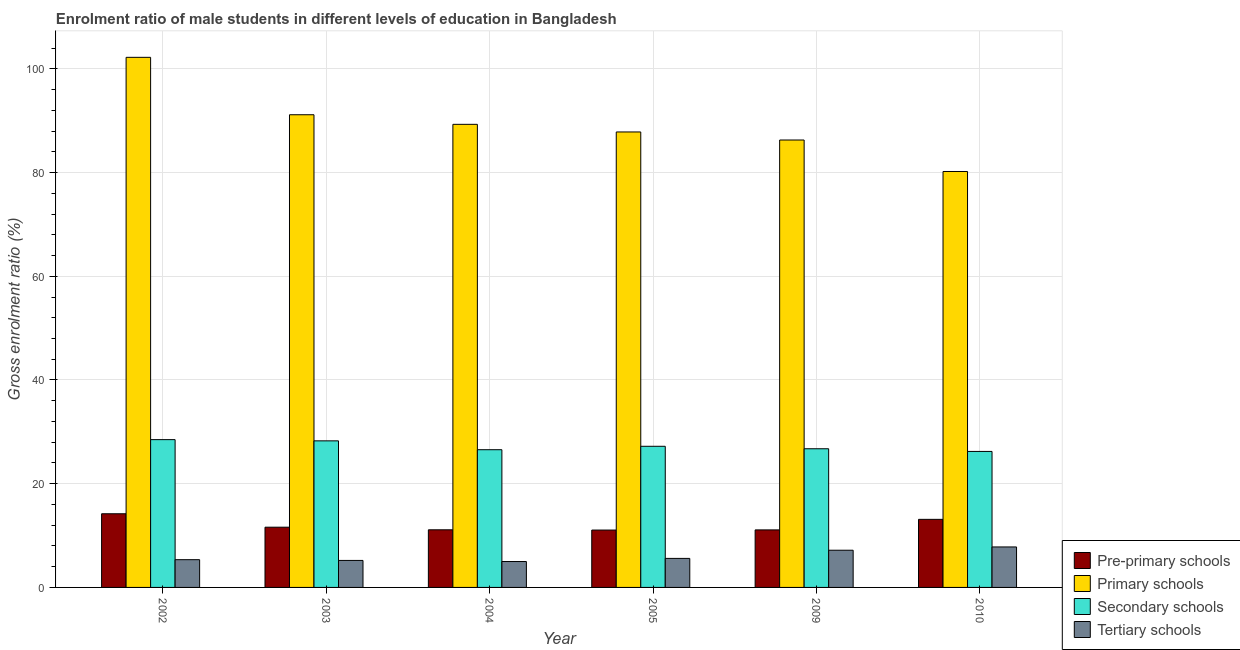How many different coloured bars are there?
Your response must be concise. 4. How many groups of bars are there?
Keep it short and to the point. 6. What is the label of the 3rd group of bars from the left?
Give a very brief answer. 2004. In how many cases, is the number of bars for a given year not equal to the number of legend labels?
Give a very brief answer. 0. What is the gross enrolment ratio(female) in tertiary schools in 2004?
Provide a short and direct response. 5. Across all years, what is the maximum gross enrolment ratio(female) in secondary schools?
Your answer should be very brief. 28.5. Across all years, what is the minimum gross enrolment ratio(female) in tertiary schools?
Make the answer very short. 5. In which year was the gross enrolment ratio(female) in pre-primary schools maximum?
Keep it short and to the point. 2002. What is the total gross enrolment ratio(female) in tertiary schools in the graph?
Your answer should be very brief. 36.13. What is the difference between the gross enrolment ratio(female) in tertiary schools in 2003 and that in 2004?
Ensure brevity in your answer.  0.21. What is the difference between the gross enrolment ratio(female) in primary schools in 2004 and the gross enrolment ratio(female) in pre-primary schools in 2010?
Make the answer very short. 9.09. What is the average gross enrolment ratio(female) in primary schools per year?
Ensure brevity in your answer.  89.5. In the year 2009, what is the difference between the gross enrolment ratio(female) in primary schools and gross enrolment ratio(female) in pre-primary schools?
Your response must be concise. 0. What is the ratio of the gross enrolment ratio(female) in secondary schools in 2009 to that in 2010?
Your response must be concise. 1.02. What is the difference between the highest and the second highest gross enrolment ratio(female) in pre-primary schools?
Your answer should be very brief. 1.08. What is the difference between the highest and the lowest gross enrolment ratio(female) in pre-primary schools?
Make the answer very short. 3.14. Is the sum of the gross enrolment ratio(female) in primary schools in 2005 and 2009 greater than the maximum gross enrolment ratio(female) in pre-primary schools across all years?
Provide a short and direct response. Yes. What does the 1st bar from the left in 2003 represents?
Provide a short and direct response. Pre-primary schools. What does the 4th bar from the right in 2004 represents?
Provide a short and direct response. Pre-primary schools. Are all the bars in the graph horizontal?
Offer a terse response. No. Are the values on the major ticks of Y-axis written in scientific E-notation?
Keep it short and to the point. No. Does the graph contain grids?
Make the answer very short. Yes. Where does the legend appear in the graph?
Your response must be concise. Bottom right. How are the legend labels stacked?
Give a very brief answer. Vertical. What is the title of the graph?
Provide a succinct answer. Enrolment ratio of male students in different levels of education in Bangladesh. What is the label or title of the X-axis?
Offer a terse response. Year. What is the Gross enrolment ratio (%) in Pre-primary schools in 2002?
Your answer should be compact. 14.21. What is the Gross enrolment ratio (%) of Primary schools in 2002?
Give a very brief answer. 102.22. What is the Gross enrolment ratio (%) in Secondary schools in 2002?
Make the answer very short. 28.5. What is the Gross enrolment ratio (%) in Tertiary schools in 2002?
Make the answer very short. 5.35. What is the Gross enrolment ratio (%) in Pre-primary schools in 2003?
Make the answer very short. 11.61. What is the Gross enrolment ratio (%) in Primary schools in 2003?
Give a very brief answer. 91.15. What is the Gross enrolment ratio (%) in Secondary schools in 2003?
Your response must be concise. 28.26. What is the Gross enrolment ratio (%) in Tertiary schools in 2003?
Offer a terse response. 5.2. What is the Gross enrolment ratio (%) of Pre-primary schools in 2004?
Offer a terse response. 11.11. What is the Gross enrolment ratio (%) of Primary schools in 2004?
Offer a very short reply. 89.3. What is the Gross enrolment ratio (%) of Secondary schools in 2004?
Offer a very short reply. 26.56. What is the Gross enrolment ratio (%) of Tertiary schools in 2004?
Offer a very short reply. 5. What is the Gross enrolment ratio (%) in Pre-primary schools in 2005?
Provide a short and direct response. 11.06. What is the Gross enrolment ratio (%) in Primary schools in 2005?
Make the answer very short. 87.83. What is the Gross enrolment ratio (%) of Secondary schools in 2005?
Offer a very short reply. 27.22. What is the Gross enrolment ratio (%) of Tertiary schools in 2005?
Provide a succinct answer. 5.6. What is the Gross enrolment ratio (%) of Pre-primary schools in 2009?
Give a very brief answer. 11.09. What is the Gross enrolment ratio (%) of Primary schools in 2009?
Make the answer very short. 86.28. What is the Gross enrolment ratio (%) of Secondary schools in 2009?
Make the answer very short. 26.74. What is the Gross enrolment ratio (%) of Tertiary schools in 2009?
Your answer should be very brief. 7.17. What is the Gross enrolment ratio (%) in Pre-primary schools in 2010?
Your response must be concise. 13.13. What is the Gross enrolment ratio (%) in Primary schools in 2010?
Offer a very short reply. 80.21. What is the Gross enrolment ratio (%) of Secondary schools in 2010?
Provide a short and direct response. 26.23. What is the Gross enrolment ratio (%) of Tertiary schools in 2010?
Make the answer very short. 7.81. Across all years, what is the maximum Gross enrolment ratio (%) in Pre-primary schools?
Give a very brief answer. 14.21. Across all years, what is the maximum Gross enrolment ratio (%) in Primary schools?
Offer a very short reply. 102.22. Across all years, what is the maximum Gross enrolment ratio (%) of Secondary schools?
Your response must be concise. 28.5. Across all years, what is the maximum Gross enrolment ratio (%) of Tertiary schools?
Your response must be concise. 7.81. Across all years, what is the minimum Gross enrolment ratio (%) of Pre-primary schools?
Make the answer very short. 11.06. Across all years, what is the minimum Gross enrolment ratio (%) in Primary schools?
Provide a succinct answer. 80.21. Across all years, what is the minimum Gross enrolment ratio (%) of Secondary schools?
Offer a very short reply. 26.23. Across all years, what is the minimum Gross enrolment ratio (%) of Tertiary schools?
Provide a succinct answer. 5. What is the total Gross enrolment ratio (%) of Pre-primary schools in the graph?
Ensure brevity in your answer.  72.22. What is the total Gross enrolment ratio (%) of Primary schools in the graph?
Offer a terse response. 536.99. What is the total Gross enrolment ratio (%) in Secondary schools in the graph?
Provide a short and direct response. 163.51. What is the total Gross enrolment ratio (%) in Tertiary schools in the graph?
Offer a very short reply. 36.13. What is the difference between the Gross enrolment ratio (%) of Pre-primary schools in 2002 and that in 2003?
Keep it short and to the point. 2.59. What is the difference between the Gross enrolment ratio (%) in Primary schools in 2002 and that in 2003?
Give a very brief answer. 11.07. What is the difference between the Gross enrolment ratio (%) of Secondary schools in 2002 and that in 2003?
Ensure brevity in your answer.  0.24. What is the difference between the Gross enrolment ratio (%) in Tertiary schools in 2002 and that in 2003?
Make the answer very short. 0.15. What is the difference between the Gross enrolment ratio (%) in Pre-primary schools in 2002 and that in 2004?
Offer a very short reply. 3.09. What is the difference between the Gross enrolment ratio (%) of Primary schools in 2002 and that in 2004?
Give a very brief answer. 12.92. What is the difference between the Gross enrolment ratio (%) of Secondary schools in 2002 and that in 2004?
Make the answer very short. 1.94. What is the difference between the Gross enrolment ratio (%) in Tertiary schools in 2002 and that in 2004?
Ensure brevity in your answer.  0.36. What is the difference between the Gross enrolment ratio (%) in Pre-primary schools in 2002 and that in 2005?
Offer a terse response. 3.14. What is the difference between the Gross enrolment ratio (%) of Primary schools in 2002 and that in 2005?
Offer a terse response. 14.39. What is the difference between the Gross enrolment ratio (%) in Secondary schools in 2002 and that in 2005?
Your response must be concise. 1.28. What is the difference between the Gross enrolment ratio (%) of Tertiary schools in 2002 and that in 2005?
Ensure brevity in your answer.  -0.24. What is the difference between the Gross enrolment ratio (%) in Pre-primary schools in 2002 and that in 2009?
Make the answer very short. 3.11. What is the difference between the Gross enrolment ratio (%) of Primary schools in 2002 and that in 2009?
Your answer should be very brief. 15.94. What is the difference between the Gross enrolment ratio (%) of Secondary schools in 2002 and that in 2009?
Make the answer very short. 1.76. What is the difference between the Gross enrolment ratio (%) in Tertiary schools in 2002 and that in 2009?
Your answer should be compact. -1.82. What is the difference between the Gross enrolment ratio (%) in Pre-primary schools in 2002 and that in 2010?
Ensure brevity in your answer.  1.08. What is the difference between the Gross enrolment ratio (%) of Primary schools in 2002 and that in 2010?
Provide a succinct answer. 22.01. What is the difference between the Gross enrolment ratio (%) of Secondary schools in 2002 and that in 2010?
Your answer should be very brief. 2.28. What is the difference between the Gross enrolment ratio (%) in Tertiary schools in 2002 and that in 2010?
Ensure brevity in your answer.  -2.46. What is the difference between the Gross enrolment ratio (%) of Pre-primary schools in 2003 and that in 2004?
Keep it short and to the point. 0.5. What is the difference between the Gross enrolment ratio (%) in Primary schools in 2003 and that in 2004?
Ensure brevity in your answer.  1.85. What is the difference between the Gross enrolment ratio (%) of Secondary schools in 2003 and that in 2004?
Make the answer very short. 1.71. What is the difference between the Gross enrolment ratio (%) of Tertiary schools in 2003 and that in 2004?
Offer a terse response. 0.21. What is the difference between the Gross enrolment ratio (%) of Pre-primary schools in 2003 and that in 2005?
Your response must be concise. 0.55. What is the difference between the Gross enrolment ratio (%) of Primary schools in 2003 and that in 2005?
Your answer should be compact. 3.32. What is the difference between the Gross enrolment ratio (%) of Secondary schools in 2003 and that in 2005?
Make the answer very short. 1.05. What is the difference between the Gross enrolment ratio (%) in Tertiary schools in 2003 and that in 2005?
Offer a terse response. -0.39. What is the difference between the Gross enrolment ratio (%) in Pre-primary schools in 2003 and that in 2009?
Ensure brevity in your answer.  0.52. What is the difference between the Gross enrolment ratio (%) in Primary schools in 2003 and that in 2009?
Your answer should be very brief. 4.87. What is the difference between the Gross enrolment ratio (%) of Secondary schools in 2003 and that in 2009?
Offer a very short reply. 1.52. What is the difference between the Gross enrolment ratio (%) in Tertiary schools in 2003 and that in 2009?
Your answer should be compact. -1.97. What is the difference between the Gross enrolment ratio (%) in Pre-primary schools in 2003 and that in 2010?
Offer a terse response. -1.51. What is the difference between the Gross enrolment ratio (%) in Primary schools in 2003 and that in 2010?
Ensure brevity in your answer.  10.94. What is the difference between the Gross enrolment ratio (%) of Secondary schools in 2003 and that in 2010?
Ensure brevity in your answer.  2.04. What is the difference between the Gross enrolment ratio (%) in Tertiary schools in 2003 and that in 2010?
Your response must be concise. -2.6. What is the difference between the Gross enrolment ratio (%) of Pre-primary schools in 2004 and that in 2005?
Ensure brevity in your answer.  0.05. What is the difference between the Gross enrolment ratio (%) of Primary schools in 2004 and that in 2005?
Keep it short and to the point. 1.47. What is the difference between the Gross enrolment ratio (%) of Secondary schools in 2004 and that in 2005?
Give a very brief answer. -0.66. What is the difference between the Gross enrolment ratio (%) of Tertiary schools in 2004 and that in 2005?
Provide a short and direct response. -0.6. What is the difference between the Gross enrolment ratio (%) in Pre-primary schools in 2004 and that in 2009?
Your answer should be compact. 0.02. What is the difference between the Gross enrolment ratio (%) in Primary schools in 2004 and that in 2009?
Your answer should be very brief. 3.02. What is the difference between the Gross enrolment ratio (%) of Secondary schools in 2004 and that in 2009?
Keep it short and to the point. -0.18. What is the difference between the Gross enrolment ratio (%) of Tertiary schools in 2004 and that in 2009?
Ensure brevity in your answer.  -2.18. What is the difference between the Gross enrolment ratio (%) of Pre-primary schools in 2004 and that in 2010?
Offer a terse response. -2.01. What is the difference between the Gross enrolment ratio (%) of Primary schools in 2004 and that in 2010?
Provide a succinct answer. 9.09. What is the difference between the Gross enrolment ratio (%) of Secondary schools in 2004 and that in 2010?
Provide a succinct answer. 0.33. What is the difference between the Gross enrolment ratio (%) in Tertiary schools in 2004 and that in 2010?
Provide a short and direct response. -2.81. What is the difference between the Gross enrolment ratio (%) of Pre-primary schools in 2005 and that in 2009?
Your answer should be compact. -0.03. What is the difference between the Gross enrolment ratio (%) of Primary schools in 2005 and that in 2009?
Your answer should be compact. 1.55. What is the difference between the Gross enrolment ratio (%) of Secondary schools in 2005 and that in 2009?
Offer a very short reply. 0.48. What is the difference between the Gross enrolment ratio (%) of Tertiary schools in 2005 and that in 2009?
Your answer should be very brief. -1.58. What is the difference between the Gross enrolment ratio (%) in Pre-primary schools in 2005 and that in 2010?
Provide a succinct answer. -2.06. What is the difference between the Gross enrolment ratio (%) in Primary schools in 2005 and that in 2010?
Keep it short and to the point. 7.62. What is the difference between the Gross enrolment ratio (%) of Tertiary schools in 2005 and that in 2010?
Give a very brief answer. -2.21. What is the difference between the Gross enrolment ratio (%) in Pre-primary schools in 2009 and that in 2010?
Offer a terse response. -2.03. What is the difference between the Gross enrolment ratio (%) in Primary schools in 2009 and that in 2010?
Make the answer very short. 6.07. What is the difference between the Gross enrolment ratio (%) of Secondary schools in 2009 and that in 2010?
Your response must be concise. 0.52. What is the difference between the Gross enrolment ratio (%) of Tertiary schools in 2009 and that in 2010?
Your answer should be very brief. -0.63. What is the difference between the Gross enrolment ratio (%) in Pre-primary schools in 2002 and the Gross enrolment ratio (%) in Primary schools in 2003?
Make the answer very short. -76.94. What is the difference between the Gross enrolment ratio (%) in Pre-primary schools in 2002 and the Gross enrolment ratio (%) in Secondary schools in 2003?
Provide a short and direct response. -14.06. What is the difference between the Gross enrolment ratio (%) in Pre-primary schools in 2002 and the Gross enrolment ratio (%) in Tertiary schools in 2003?
Make the answer very short. 9. What is the difference between the Gross enrolment ratio (%) in Primary schools in 2002 and the Gross enrolment ratio (%) in Secondary schools in 2003?
Keep it short and to the point. 73.96. What is the difference between the Gross enrolment ratio (%) of Primary schools in 2002 and the Gross enrolment ratio (%) of Tertiary schools in 2003?
Make the answer very short. 97.02. What is the difference between the Gross enrolment ratio (%) in Secondary schools in 2002 and the Gross enrolment ratio (%) in Tertiary schools in 2003?
Your response must be concise. 23.3. What is the difference between the Gross enrolment ratio (%) in Pre-primary schools in 2002 and the Gross enrolment ratio (%) in Primary schools in 2004?
Offer a very short reply. -75.09. What is the difference between the Gross enrolment ratio (%) in Pre-primary schools in 2002 and the Gross enrolment ratio (%) in Secondary schools in 2004?
Keep it short and to the point. -12.35. What is the difference between the Gross enrolment ratio (%) of Pre-primary schools in 2002 and the Gross enrolment ratio (%) of Tertiary schools in 2004?
Your response must be concise. 9.21. What is the difference between the Gross enrolment ratio (%) of Primary schools in 2002 and the Gross enrolment ratio (%) of Secondary schools in 2004?
Make the answer very short. 75.66. What is the difference between the Gross enrolment ratio (%) of Primary schools in 2002 and the Gross enrolment ratio (%) of Tertiary schools in 2004?
Provide a short and direct response. 97.23. What is the difference between the Gross enrolment ratio (%) of Secondary schools in 2002 and the Gross enrolment ratio (%) of Tertiary schools in 2004?
Keep it short and to the point. 23.5. What is the difference between the Gross enrolment ratio (%) in Pre-primary schools in 2002 and the Gross enrolment ratio (%) in Primary schools in 2005?
Keep it short and to the point. -73.63. What is the difference between the Gross enrolment ratio (%) of Pre-primary schools in 2002 and the Gross enrolment ratio (%) of Secondary schools in 2005?
Give a very brief answer. -13.01. What is the difference between the Gross enrolment ratio (%) of Pre-primary schools in 2002 and the Gross enrolment ratio (%) of Tertiary schools in 2005?
Your answer should be compact. 8.61. What is the difference between the Gross enrolment ratio (%) of Primary schools in 2002 and the Gross enrolment ratio (%) of Secondary schools in 2005?
Give a very brief answer. 75.01. What is the difference between the Gross enrolment ratio (%) in Primary schools in 2002 and the Gross enrolment ratio (%) in Tertiary schools in 2005?
Provide a short and direct response. 96.63. What is the difference between the Gross enrolment ratio (%) in Secondary schools in 2002 and the Gross enrolment ratio (%) in Tertiary schools in 2005?
Offer a terse response. 22.9. What is the difference between the Gross enrolment ratio (%) in Pre-primary schools in 2002 and the Gross enrolment ratio (%) in Primary schools in 2009?
Keep it short and to the point. -72.07. What is the difference between the Gross enrolment ratio (%) in Pre-primary schools in 2002 and the Gross enrolment ratio (%) in Secondary schools in 2009?
Make the answer very short. -12.54. What is the difference between the Gross enrolment ratio (%) in Pre-primary schools in 2002 and the Gross enrolment ratio (%) in Tertiary schools in 2009?
Offer a very short reply. 7.03. What is the difference between the Gross enrolment ratio (%) of Primary schools in 2002 and the Gross enrolment ratio (%) of Secondary schools in 2009?
Offer a very short reply. 75.48. What is the difference between the Gross enrolment ratio (%) of Primary schools in 2002 and the Gross enrolment ratio (%) of Tertiary schools in 2009?
Your answer should be very brief. 95.05. What is the difference between the Gross enrolment ratio (%) in Secondary schools in 2002 and the Gross enrolment ratio (%) in Tertiary schools in 2009?
Give a very brief answer. 21.33. What is the difference between the Gross enrolment ratio (%) of Pre-primary schools in 2002 and the Gross enrolment ratio (%) of Primary schools in 2010?
Keep it short and to the point. -66. What is the difference between the Gross enrolment ratio (%) of Pre-primary schools in 2002 and the Gross enrolment ratio (%) of Secondary schools in 2010?
Give a very brief answer. -12.02. What is the difference between the Gross enrolment ratio (%) in Pre-primary schools in 2002 and the Gross enrolment ratio (%) in Tertiary schools in 2010?
Your answer should be very brief. 6.4. What is the difference between the Gross enrolment ratio (%) in Primary schools in 2002 and the Gross enrolment ratio (%) in Secondary schools in 2010?
Give a very brief answer. 76. What is the difference between the Gross enrolment ratio (%) in Primary schools in 2002 and the Gross enrolment ratio (%) in Tertiary schools in 2010?
Your response must be concise. 94.42. What is the difference between the Gross enrolment ratio (%) of Secondary schools in 2002 and the Gross enrolment ratio (%) of Tertiary schools in 2010?
Your response must be concise. 20.69. What is the difference between the Gross enrolment ratio (%) of Pre-primary schools in 2003 and the Gross enrolment ratio (%) of Primary schools in 2004?
Give a very brief answer. -77.69. What is the difference between the Gross enrolment ratio (%) in Pre-primary schools in 2003 and the Gross enrolment ratio (%) in Secondary schools in 2004?
Give a very brief answer. -14.94. What is the difference between the Gross enrolment ratio (%) of Pre-primary schools in 2003 and the Gross enrolment ratio (%) of Tertiary schools in 2004?
Your answer should be very brief. 6.62. What is the difference between the Gross enrolment ratio (%) of Primary schools in 2003 and the Gross enrolment ratio (%) of Secondary schools in 2004?
Provide a succinct answer. 64.59. What is the difference between the Gross enrolment ratio (%) in Primary schools in 2003 and the Gross enrolment ratio (%) in Tertiary schools in 2004?
Provide a succinct answer. 86.15. What is the difference between the Gross enrolment ratio (%) of Secondary schools in 2003 and the Gross enrolment ratio (%) of Tertiary schools in 2004?
Make the answer very short. 23.27. What is the difference between the Gross enrolment ratio (%) in Pre-primary schools in 2003 and the Gross enrolment ratio (%) in Primary schools in 2005?
Offer a terse response. -76.22. What is the difference between the Gross enrolment ratio (%) of Pre-primary schools in 2003 and the Gross enrolment ratio (%) of Secondary schools in 2005?
Give a very brief answer. -15.6. What is the difference between the Gross enrolment ratio (%) in Pre-primary schools in 2003 and the Gross enrolment ratio (%) in Tertiary schools in 2005?
Your response must be concise. 6.02. What is the difference between the Gross enrolment ratio (%) of Primary schools in 2003 and the Gross enrolment ratio (%) of Secondary schools in 2005?
Offer a very short reply. 63.93. What is the difference between the Gross enrolment ratio (%) in Primary schools in 2003 and the Gross enrolment ratio (%) in Tertiary schools in 2005?
Offer a very short reply. 85.55. What is the difference between the Gross enrolment ratio (%) of Secondary schools in 2003 and the Gross enrolment ratio (%) of Tertiary schools in 2005?
Offer a terse response. 22.67. What is the difference between the Gross enrolment ratio (%) in Pre-primary schools in 2003 and the Gross enrolment ratio (%) in Primary schools in 2009?
Your answer should be compact. -74.66. What is the difference between the Gross enrolment ratio (%) in Pre-primary schools in 2003 and the Gross enrolment ratio (%) in Secondary schools in 2009?
Give a very brief answer. -15.13. What is the difference between the Gross enrolment ratio (%) of Pre-primary schools in 2003 and the Gross enrolment ratio (%) of Tertiary schools in 2009?
Give a very brief answer. 4.44. What is the difference between the Gross enrolment ratio (%) in Primary schools in 2003 and the Gross enrolment ratio (%) in Secondary schools in 2009?
Provide a succinct answer. 64.41. What is the difference between the Gross enrolment ratio (%) of Primary schools in 2003 and the Gross enrolment ratio (%) of Tertiary schools in 2009?
Ensure brevity in your answer.  83.98. What is the difference between the Gross enrolment ratio (%) in Secondary schools in 2003 and the Gross enrolment ratio (%) in Tertiary schools in 2009?
Offer a terse response. 21.09. What is the difference between the Gross enrolment ratio (%) of Pre-primary schools in 2003 and the Gross enrolment ratio (%) of Primary schools in 2010?
Your response must be concise. -68.59. What is the difference between the Gross enrolment ratio (%) in Pre-primary schools in 2003 and the Gross enrolment ratio (%) in Secondary schools in 2010?
Offer a very short reply. -14.61. What is the difference between the Gross enrolment ratio (%) of Pre-primary schools in 2003 and the Gross enrolment ratio (%) of Tertiary schools in 2010?
Keep it short and to the point. 3.81. What is the difference between the Gross enrolment ratio (%) in Primary schools in 2003 and the Gross enrolment ratio (%) in Secondary schools in 2010?
Your response must be concise. 64.92. What is the difference between the Gross enrolment ratio (%) of Primary schools in 2003 and the Gross enrolment ratio (%) of Tertiary schools in 2010?
Provide a succinct answer. 83.34. What is the difference between the Gross enrolment ratio (%) of Secondary schools in 2003 and the Gross enrolment ratio (%) of Tertiary schools in 2010?
Keep it short and to the point. 20.46. What is the difference between the Gross enrolment ratio (%) in Pre-primary schools in 2004 and the Gross enrolment ratio (%) in Primary schools in 2005?
Your response must be concise. -76.72. What is the difference between the Gross enrolment ratio (%) of Pre-primary schools in 2004 and the Gross enrolment ratio (%) of Secondary schools in 2005?
Ensure brevity in your answer.  -16.11. What is the difference between the Gross enrolment ratio (%) in Pre-primary schools in 2004 and the Gross enrolment ratio (%) in Tertiary schools in 2005?
Your answer should be compact. 5.52. What is the difference between the Gross enrolment ratio (%) of Primary schools in 2004 and the Gross enrolment ratio (%) of Secondary schools in 2005?
Give a very brief answer. 62.08. What is the difference between the Gross enrolment ratio (%) of Primary schools in 2004 and the Gross enrolment ratio (%) of Tertiary schools in 2005?
Make the answer very short. 83.7. What is the difference between the Gross enrolment ratio (%) of Secondary schools in 2004 and the Gross enrolment ratio (%) of Tertiary schools in 2005?
Ensure brevity in your answer.  20.96. What is the difference between the Gross enrolment ratio (%) of Pre-primary schools in 2004 and the Gross enrolment ratio (%) of Primary schools in 2009?
Offer a very short reply. -75.17. What is the difference between the Gross enrolment ratio (%) of Pre-primary schools in 2004 and the Gross enrolment ratio (%) of Secondary schools in 2009?
Make the answer very short. -15.63. What is the difference between the Gross enrolment ratio (%) of Pre-primary schools in 2004 and the Gross enrolment ratio (%) of Tertiary schools in 2009?
Give a very brief answer. 3.94. What is the difference between the Gross enrolment ratio (%) of Primary schools in 2004 and the Gross enrolment ratio (%) of Secondary schools in 2009?
Offer a terse response. 62.56. What is the difference between the Gross enrolment ratio (%) in Primary schools in 2004 and the Gross enrolment ratio (%) in Tertiary schools in 2009?
Ensure brevity in your answer.  82.13. What is the difference between the Gross enrolment ratio (%) in Secondary schools in 2004 and the Gross enrolment ratio (%) in Tertiary schools in 2009?
Keep it short and to the point. 19.38. What is the difference between the Gross enrolment ratio (%) of Pre-primary schools in 2004 and the Gross enrolment ratio (%) of Primary schools in 2010?
Your answer should be very brief. -69.1. What is the difference between the Gross enrolment ratio (%) in Pre-primary schools in 2004 and the Gross enrolment ratio (%) in Secondary schools in 2010?
Give a very brief answer. -15.11. What is the difference between the Gross enrolment ratio (%) in Pre-primary schools in 2004 and the Gross enrolment ratio (%) in Tertiary schools in 2010?
Offer a very short reply. 3.31. What is the difference between the Gross enrolment ratio (%) in Primary schools in 2004 and the Gross enrolment ratio (%) in Secondary schools in 2010?
Your response must be concise. 63.07. What is the difference between the Gross enrolment ratio (%) of Primary schools in 2004 and the Gross enrolment ratio (%) of Tertiary schools in 2010?
Your answer should be compact. 81.49. What is the difference between the Gross enrolment ratio (%) in Secondary schools in 2004 and the Gross enrolment ratio (%) in Tertiary schools in 2010?
Offer a terse response. 18.75. What is the difference between the Gross enrolment ratio (%) in Pre-primary schools in 2005 and the Gross enrolment ratio (%) in Primary schools in 2009?
Offer a very short reply. -75.22. What is the difference between the Gross enrolment ratio (%) of Pre-primary schools in 2005 and the Gross enrolment ratio (%) of Secondary schools in 2009?
Keep it short and to the point. -15.68. What is the difference between the Gross enrolment ratio (%) of Pre-primary schools in 2005 and the Gross enrolment ratio (%) of Tertiary schools in 2009?
Your answer should be compact. 3.89. What is the difference between the Gross enrolment ratio (%) of Primary schools in 2005 and the Gross enrolment ratio (%) of Secondary schools in 2009?
Make the answer very short. 61.09. What is the difference between the Gross enrolment ratio (%) of Primary schools in 2005 and the Gross enrolment ratio (%) of Tertiary schools in 2009?
Ensure brevity in your answer.  80.66. What is the difference between the Gross enrolment ratio (%) of Secondary schools in 2005 and the Gross enrolment ratio (%) of Tertiary schools in 2009?
Your answer should be very brief. 20.04. What is the difference between the Gross enrolment ratio (%) in Pre-primary schools in 2005 and the Gross enrolment ratio (%) in Primary schools in 2010?
Your response must be concise. -69.14. What is the difference between the Gross enrolment ratio (%) in Pre-primary schools in 2005 and the Gross enrolment ratio (%) in Secondary schools in 2010?
Keep it short and to the point. -15.16. What is the difference between the Gross enrolment ratio (%) of Pre-primary schools in 2005 and the Gross enrolment ratio (%) of Tertiary schools in 2010?
Offer a very short reply. 3.26. What is the difference between the Gross enrolment ratio (%) of Primary schools in 2005 and the Gross enrolment ratio (%) of Secondary schools in 2010?
Your answer should be very brief. 61.61. What is the difference between the Gross enrolment ratio (%) in Primary schools in 2005 and the Gross enrolment ratio (%) in Tertiary schools in 2010?
Your answer should be compact. 80.02. What is the difference between the Gross enrolment ratio (%) in Secondary schools in 2005 and the Gross enrolment ratio (%) in Tertiary schools in 2010?
Make the answer very short. 19.41. What is the difference between the Gross enrolment ratio (%) of Pre-primary schools in 2009 and the Gross enrolment ratio (%) of Primary schools in 2010?
Keep it short and to the point. -69.11. What is the difference between the Gross enrolment ratio (%) of Pre-primary schools in 2009 and the Gross enrolment ratio (%) of Secondary schools in 2010?
Ensure brevity in your answer.  -15.13. What is the difference between the Gross enrolment ratio (%) in Pre-primary schools in 2009 and the Gross enrolment ratio (%) in Tertiary schools in 2010?
Your response must be concise. 3.29. What is the difference between the Gross enrolment ratio (%) in Primary schools in 2009 and the Gross enrolment ratio (%) in Secondary schools in 2010?
Keep it short and to the point. 60.05. What is the difference between the Gross enrolment ratio (%) in Primary schools in 2009 and the Gross enrolment ratio (%) in Tertiary schools in 2010?
Make the answer very short. 78.47. What is the difference between the Gross enrolment ratio (%) of Secondary schools in 2009 and the Gross enrolment ratio (%) of Tertiary schools in 2010?
Your response must be concise. 18.93. What is the average Gross enrolment ratio (%) of Pre-primary schools per year?
Ensure brevity in your answer.  12.04. What is the average Gross enrolment ratio (%) in Primary schools per year?
Your response must be concise. 89.5. What is the average Gross enrolment ratio (%) of Secondary schools per year?
Provide a short and direct response. 27.25. What is the average Gross enrolment ratio (%) in Tertiary schools per year?
Offer a terse response. 6.02. In the year 2002, what is the difference between the Gross enrolment ratio (%) of Pre-primary schools and Gross enrolment ratio (%) of Primary schools?
Your answer should be compact. -88.02. In the year 2002, what is the difference between the Gross enrolment ratio (%) in Pre-primary schools and Gross enrolment ratio (%) in Secondary schools?
Provide a succinct answer. -14.3. In the year 2002, what is the difference between the Gross enrolment ratio (%) of Pre-primary schools and Gross enrolment ratio (%) of Tertiary schools?
Your response must be concise. 8.85. In the year 2002, what is the difference between the Gross enrolment ratio (%) of Primary schools and Gross enrolment ratio (%) of Secondary schools?
Give a very brief answer. 73.72. In the year 2002, what is the difference between the Gross enrolment ratio (%) in Primary schools and Gross enrolment ratio (%) in Tertiary schools?
Offer a terse response. 96.87. In the year 2002, what is the difference between the Gross enrolment ratio (%) of Secondary schools and Gross enrolment ratio (%) of Tertiary schools?
Offer a very short reply. 23.15. In the year 2003, what is the difference between the Gross enrolment ratio (%) in Pre-primary schools and Gross enrolment ratio (%) in Primary schools?
Provide a short and direct response. -79.54. In the year 2003, what is the difference between the Gross enrolment ratio (%) in Pre-primary schools and Gross enrolment ratio (%) in Secondary schools?
Make the answer very short. -16.65. In the year 2003, what is the difference between the Gross enrolment ratio (%) in Pre-primary schools and Gross enrolment ratio (%) in Tertiary schools?
Your answer should be compact. 6.41. In the year 2003, what is the difference between the Gross enrolment ratio (%) of Primary schools and Gross enrolment ratio (%) of Secondary schools?
Your answer should be very brief. 62.89. In the year 2003, what is the difference between the Gross enrolment ratio (%) in Primary schools and Gross enrolment ratio (%) in Tertiary schools?
Ensure brevity in your answer.  85.95. In the year 2003, what is the difference between the Gross enrolment ratio (%) in Secondary schools and Gross enrolment ratio (%) in Tertiary schools?
Your answer should be very brief. 23.06. In the year 2004, what is the difference between the Gross enrolment ratio (%) in Pre-primary schools and Gross enrolment ratio (%) in Primary schools?
Keep it short and to the point. -78.19. In the year 2004, what is the difference between the Gross enrolment ratio (%) in Pre-primary schools and Gross enrolment ratio (%) in Secondary schools?
Give a very brief answer. -15.45. In the year 2004, what is the difference between the Gross enrolment ratio (%) in Pre-primary schools and Gross enrolment ratio (%) in Tertiary schools?
Make the answer very short. 6.12. In the year 2004, what is the difference between the Gross enrolment ratio (%) of Primary schools and Gross enrolment ratio (%) of Secondary schools?
Offer a very short reply. 62.74. In the year 2004, what is the difference between the Gross enrolment ratio (%) in Primary schools and Gross enrolment ratio (%) in Tertiary schools?
Provide a short and direct response. 84.3. In the year 2004, what is the difference between the Gross enrolment ratio (%) of Secondary schools and Gross enrolment ratio (%) of Tertiary schools?
Ensure brevity in your answer.  21.56. In the year 2005, what is the difference between the Gross enrolment ratio (%) in Pre-primary schools and Gross enrolment ratio (%) in Primary schools?
Offer a terse response. -76.77. In the year 2005, what is the difference between the Gross enrolment ratio (%) of Pre-primary schools and Gross enrolment ratio (%) of Secondary schools?
Your response must be concise. -16.15. In the year 2005, what is the difference between the Gross enrolment ratio (%) in Pre-primary schools and Gross enrolment ratio (%) in Tertiary schools?
Offer a terse response. 5.47. In the year 2005, what is the difference between the Gross enrolment ratio (%) of Primary schools and Gross enrolment ratio (%) of Secondary schools?
Your answer should be very brief. 60.61. In the year 2005, what is the difference between the Gross enrolment ratio (%) of Primary schools and Gross enrolment ratio (%) of Tertiary schools?
Keep it short and to the point. 82.23. In the year 2005, what is the difference between the Gross enrolment ratio (%) of Secondary schools and Gross enrolment ratio (%) of Tertiary schools?
Your answer should be compact. 21.62. In the year 2009, what is the difference between the Gross enrolment ratio (%) of Pre-primary schools and Gross enrolment ratio (%) of Primary schools?
Ensure brevity in your answer.  -75.19. In the year 2009, what is the difference between the Gross enrolment ratio (%) of Pre-primary schools and Gross enrolment ratio (%) of Secondary schools?
Keep it short and to the point. -15.65. In the year 2009, what is the difference between the Gross enrolment ratio (%) in Pre-primary schools and Gross enrolment ratio (%) in Tertiary schools?
Your answer should be very brief. 3.92. In the year 2009, what is the difference between the Gross enrolment ratio (%) of Primary schools and Gross enrolment ratio (%) of Secondary schools?
Keep it short and to the point. 59.54. In the year 2009, what is the difference between the Gross enrolment ratio (%) of Primary schools and Gross enrolment ratio (%) of Tertiary schools?
Ensure brevity in your answer.  79.1. In the year 2009, what is the difference between the Gross enrolment ratio (%) in Secondary schools and Gross enrolment ratio (%) in Tertiary schools?
Offer a terse response. 19.57. In the year 2010, what is the difference between the Gross enrolment ratio (%) of Pre-primary schools and Gross enrolment ratio (%) of Primary schools?
Provide a short and direct response. -67.08. In the year 2010, what is the difference between the Gross enrolment ratio (%) of Pre-primary schools and Gross enrolment ratio (%) of Secondary schools?
Your answer should be compact. -13.1. In the year 2010, what is the difference between the Gross enrolment ratio (%) of Pre-primary schools and Gross enrolment ratio (%) of Tertiary schools?
Offer a very short reply. 5.32. In the year 2010, what is the difference between the Gross enrolment ratio (%) of Primary schools and Gross enrolment ratio (%) of Secondary schools?
Offer a very short reply. 53.98. In the year 2010, what is the difference between the Gross enrolment ratio (%) of Primary schools and Gross enrolment ratio (%) of Tertiary schools?
Provide a short and direct response. 72.4. In the year 2010, what is the difference between the Gross enrolment ratio (%) of Secondary schools and Gross enrolment ratio (%) of Tertiary schools?
Your answer should be compact. 18.42. What is the ratio of the Gross enrolment ratio (%) of Pre-primary schools in 2002 to that in 2003?
Your response must be concise. 1.22. What is the ratio of the Gross enrolment ratio (%) of Primary schools in 2002 to that in 2003?
Your answer should be compact. 1.12. What is the ratio of the Gross enrolment ratio (%) of Secondary schools in 2002 to that in 2003?
Make the answer very short. 1.01. What is the ratio of the Gross enrolment ratio (%) in Tertiary schools in 2002 to that in 2003?
Offer a terse response. 1.03. What is the ratio of the Gross enrolment ratio (%) in Pre-primary schools in 2002 to that in 2004?
Your response must be concise. 1.28. What is the ratio of the Gross enrolment ratio (%) of Primary schools in 2002 to that in 2004?
Ensure brevity in your answer.  1.14. What is the ratio of the Gross enrolment ratio (%) of Secondary schools in 2002 to that in 2004?
Your answer should be compact. 1.07. What is the ratio of the Gross enrolment ratio (%) in Tertiary schools in 2002 to that in 2004?
Provide a succinct answer. 1.07. What is the ratio of the Gross enrolment ratio (%) of Pre-primary schools in 2002 to that in 2005?
Your response must be concise. 1.28. What is the ratio of the Gross enrolment ratio (%) of Primary schools in 2002 to that in 2005?
Ensure brevity in your answer.  1.16. What is the ratio of the Gross enrolment ratio (%) of Secondary schools in 2002 to that in 2005?
Your response must be concise. 1.05. What is the ratio of the Gross enrolment ratio (%) in Tertiary schools in 2002 to that in 2005?
Offer a terse response. 0.96. What is the ratio of the Gross enrolment ratio (%) in Pre-primary schools in 2002 to that in 2009?
Make the answer very short. 1.28. What is the ratio of the Gross enrolment ratio (%) of Primary schools in 2002 to that in 2009?
Keep it short and to the point. 1.18. What is the ratio of the Gross enrolment ratio (%) in Secondary schools in 2002 to that in 2009?
Provide a succinct answer. 1.07. What is the ratio of the Gross enrolment ratio (%) in Tertiary schools in 2002 to that in 2009?
Your response must be concise. 0.75. What is the ratio of the Gross enrolment ratio (%) of Pre-primary schools in 2002 to that in 2010?
Keep it short and to the point. 1.08. What is the ratio of the Gross enrolment ratio (%) in Primary schools in 2002 to that in 2010?
Your answer should be compact. 1.27. What is the ratio of the Gross enrolment ratio (%) in Secondary schools in 2002 to that in 2010?
Your answer should be very brief. 1.09. What is the ratio of the Gross enrolment ratio (%) of Tertiary schools in 2002 to that in 2010?
Your response must be concise. 0.69. What is the ratio of the Gross enrolment ratio (%) of Pre-primary schools in 2003 to that in 2004?
Your answer should be compact. 1.05. What is the ratio of the Gross enrolment ratio (%) in Primary schools in 2003 to that in 2004?
Your answer should be compact. 1.02. What is the ratio of the Gross enrolment ratio (%) of Secondary schools in 2003 to that in 2004?
Your response must be concise. 1.06. What is the ratio of the Gross enrolment ratio (%) in Tertiary schools in 2003 to that in 2004?
Offer a very short reply. 1.04. What is the ratio of the Gross enrolment ratio (%) of Pre-primary schools in 2003 to that in 2005?
Offer a very short reply. 1.05. What is the ratio of the Gross enrolment ratio (%) of Primary schools in 2003 to that in 2005?
Keep it short and to the point. 1.04. What is the ratio of the Gross enrolment ratio (%) in Tertiary schools in 2003 to that in 2005?
Your response must be concise. 0.93. What is the ratio of the Gross enrolment ratio (%) of Pre-primary schools in 2003 to that in 2009?
Your response must be concise. 1.05. What is the ratio of the Gross enrolment ratio (%) of Primary schools in 2003 to that in 2009?
Give a very brief answer. 1.06. What is the ratio of the Gross enrolment ratio (%) of Secondary schools in 2003 to that in 2009?
Give a very brief answer. 1.06. What is the ratio of the Gross enrolment ratio (%) of Tertiary schools in 2003 to that in 2009?
Your answer should be very brief. 0.73. What is the ratio of the Gross enrolment ratio (%) in Pre-primary schools in 2003 to that in 2010?
Provide a short and direct response. 0.88. What is the ratio of the Gross enrolment ratio (%) in Primary schools in 2003 to that in 2010?
Ensure brevity in your answer.  1.14. What is the ratio of the Gross enrolment ratio (%) in Secondary schools in 2003 to that in 2010?
Provide a succinct answer. 1.08. What is the ratio of the Gross enrolment ratio (%) of Tertiary schools in 2003 to that in 2010?
Ensure brevity in your answer.  0.67. What is the ratio of the Gross enrolment ratio (%) of Primary schools in 2004 to that in 2005?
Provide a short and direct response. 1.02. What is the ratio of the Gross enrolment ratio (%) of Secondary schools in 2004 to that in 2005?
Ensure brevity in your answer.  0.98. What is the ratio of the Gross enrolment ratio (%) in Tertiary schools in 2004 to that in 2005?
Your response must be concise. 0.89. What is the ratio of the Gross enrolment ratio (%) in Primary schools in 2004 to that in 2009?
Ensure brevity in your answer.  1.03. What is the ratio of the Gross enrolment ratio (%) of Secondary schools in 2004 to that in 2009?
Provide a succinct answer. 0.99. What is the ratio of the Gross enrolment ratio (%) of Tertiary schools in 2004 to that in 2009?
Ensure brevity in your answer.  0.7. What is the ratio of the Gross enrolment ratio (%) of Pre-primary schools in 2004 to that in 2010?
Ensure brevity in your answer.  0.85. What is the ratio of the Gross enrolment ratio (%) in Primary schools in 2004 to that in 2010?
Make the answer very short. 1.11. What is the ratio of the Gross enrolment ratio (%) in Secondary schools in 2004 to that in 2010?
Offer a terse response. 1.01. What is the ratio of the Gross enrolment ratio (%) in Tertiary schools in 2004 to that in 2010?
Your answer should be very brief. 0.64. What is the ratio of the Gross enrolment ratio (%) in Pre-primary schools in 2005 to that in 2009?
Your response must be concise. 1. What is the ratio of the Gross enrolment ratio (%) in Secondary schools in 2005 to that in 2009?
Provide a short and direct response. 1.02. What is the ratio of the Gross enrolment ratio (%) of Tertiary schools in 2005 to that in 2009?
Your response must be concise. 0.78. What is the ratio of the Gross enrolment ratio (%) in Pre-primary schools in 2005 to that in 2010?
Ensure brevity in your answer.  0.84. What is the ratio of the Gross enrolment ratio (%) in Primary schools in 2005 to that in 2010?
Provide a short and direct response. 1.09. What is the ratio of the Gross enrolment ratio (%) of Secondary schools in 2005 to that in 2010?
Offer a very short reply. 1.04. What is the ratio of the Gross enrolment ratio (%) of Tertiary schools in 2005 to that in 2010?
Your answer should be very brief. 0.72. What is the ratio of the Gross enrolment ratio (%) of Pre-primary schools in 2009 to that in 2010?
Your response must be concise. 0.85. What is the ratio of the Gross enrolment ratio (%) in Primary schools in 2009 to that in 2010?
Offer a terse response. 1.08. What is the ratio of the Gross enrolment ratio (%) in Secondary schools in 2009 to that in 2010?
Your response must be concise. 1.02. What is the ratio of the Gross enrolment ratio (%) of Tertiary schools in 2009 to that in 2010?
Your answer should be compact. 0.92. What is the difference between the highest and the second highest Gross enrolment ratio (%) of Pre-primary schools?
Provide a succinct answer. 1.08. What is the difference between the highest and the second highest Gross enrolment ratio (%) of Primary schools?
Give a very brief answer. 11.07. What is the difference between the highest and the second highest Gross enrolment ratio (%) in Secondary schools?
Your answer should be very brief. 0.24. What is the difference between the highest and the second highest Gross enrolment ratio (%) in Tertiary schools?
Offer a very short reply. 0.63. What is the difference between the highest and the lowest Gross enrolment ratio (%) in Pre-primary schools?
Provide a succinct answer. 3.14. What is the difference between the highest and the lowest Gross enrolment ratio (%) in Primary schools?
Make the answer very short. 22.01. What is the difference between the highest and the lowest Gross enrolment ratio (%) in Secondary schools?
Provide a succinct answer. 2.28. What is the difference between the highest and the lowest Gross enrolment ratio (%) in Tertiary schools?
Offer a terse response. 2.81. 